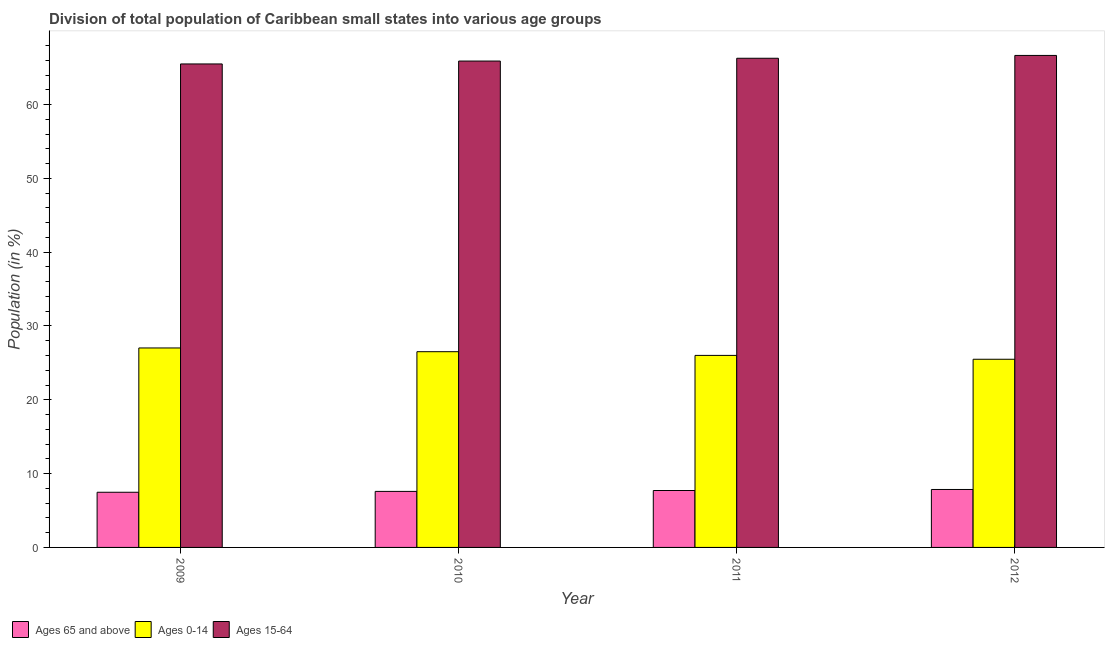How many groups of bars are there?
Give a very brief answer. 4. How many bars are there on the 1st tick from the right?
Give a very brief answer. 3. What is the percentage of population within the age-group 0-14 in 2010?
Provide a succinct answer. 26.52. Across all years, what is the maximum percentage of population within the age-group 0-14?
Ensure brevity in your answer.  27.02. Across all years, what is the minimum percentage of population within the age-group 15-64?
Your response must be concise. 65.5. In which year was the percentage of population within the age-group of 65 and above maximum?
Your answer should be compact. 2012. What is the total percentage of population within the age-group of 65 and above in the graph?
Your answer should be compact. 30.63. What is the difference between the percentage of population within the age-group of 65 and above in 2011 and that in 2012?
Provide a succinct answer. -0.14. What is the difference between the percentage of population within the age-group of 65 and above in 2011 and the percentage of population within the age-group 15-64 in 2012?
Provide a succinct answer. -0.14. What is the average percentage of population within the age-group of 65 and above per year?
Provide a succinct answer. 7.66. In how many years, is the percentage of population within the age-group 0-14 greater than 30 %?
Provide a short and direct response. 0. What is the ratio of the percentage of population within the age-group 15-64 in 2011 to that in 2012?
Make the answer very short. 0.99. What is the difference between the highest and the second highest percentage of population within the age-group 15-64?
Offer a very short reply. 0.38. What is the difference between the highest and the lowest percentage of population within the age-group of 65 and above?
Offer a terse response. 0.38. In how many years, is the percentage of population within the age-group of 65 and above greater than the average percentage of population within the age-group of 65 and above taken over all years?
Your response must be concise. 2. What does the 3rd bar from the left in 2010 represents?
Keep it short and to the point. Ages 15-64. What does the 2nd bar from the right in 2012 represents?
Ensure brevity in your answer.  Ages 0-14. Is it the case that in every year, the sum of the percentage of population within the age-group of 65 and above and percentage of population within the age-group 0-14 is greater than the percentage of population within the age-group 15-64?
Your answer should be very brief. No. How many bars are there?
Your answer should be compact. 12. Are all the bars in the graph horizontal?
Offer a very short reply. No. What is the difference between two consecutive major ticks on the Y-axis?
Make the answer very short. 10. Does the graph contain grids?
Your answer should be compact. No. How many legend labels are there?
Provide a short and direct response. 3. How are the legend labels stacked?
Provide a short and direct response. Horizontal. What is the title of the graph?
Your answer should be compact. Division of total population of Caribbean small states into various age groups
. What is the label or title of the Y-axis?
Your response must be concise. Population (in %). What is the Population (in %) of Ages 65 and above in 2009?
Your answer should be very brief. 7.48. What is the Population (in %) of Ages 0-14 in 2009?
Offer a terse response. 27.02. What is the Population (in %) in Ages 15-64 in 2009?
Ensure brevity in your answer.  65.5. What is the Population (in %) in Ages 65 and above in 2010?
Make the answer very short. 7.59. What is the Population (in %) of Ages 0-14 in 2010?
Your response must be concise. 26.52. What is the Population (in %) of Ages 15-64 in 2010?
Make the answer very short. 65.89. What is the Population (in %) of Ages 65 and above in 2011?
Your answer should be compact. 7.71. What is the Population (in %) in Ages 0-14 in 2011?
Your answer should be compact. 26.02. What is the Population (in %) in Ages 15-64 in 2011?
Ensure brevity in your answer.  66.27. What is the Population (in %) of Ages 65 and above in 2012?
Your answer should be very brief. 7.85. What is the Population (in %) in Ages 0-14 in 2012?
Provide a succinct answer. 25.49. What is the Population (in %) of Ages 15-64 in 2012?
Provide a succinct answer. 66.66. Across all years, what is the maximum Population (in %) of Ages 65 and above?
Provide a succinct answer. 7.85. Across all years, what is the maximum Population (in %) of Ages 0-14?
Give a very brief answer. 27.02. Across all years, what is the maximum Population (in %) in Ages 15-64?
Your answer should be very brief. 66.66. Across all years, what is the minimum Population (in %) of Ages 65 and above?
Your answer should be very brief. 7.48. Across all years, what is the minimum Population (in %) of Ages 0-14?
Provide a short and direct response. 25.49. Across all years, what is the minimum Population (in %) of Ages 15-64?
Your answer should be compact. 65.5. What is the total Population (in %) of Ages 65 and above in the graph?
Your answer should be compact. 30.63. What is the total Population (in %) of Ages 0-14 in the graph?
Provide a succinct answer. 105.05. What is the total Population (in %) in Ages 15-64 in the graph?
Offer a terse response. 264.32. What is the difference between the Population (in %) of Ages 65 and above in 2009 and that in 2010?
Offer a very short reply. -0.11. What is the difference between the Population (in %) of Ages 0-14 in 2009 and that in 2010?
Provide a succinct answer. 0.51. What is the difference between the Population (in %) of Ages 15-64 in 2009 and that in 2010?
Provide a succinct answer. -0.39. What is the difference between the Population (in %) in Ages 65 and above in 2009 and that in 2011?
Provide a succinct answer. -0.24. What is the difference between the Population (in %) in Ages 0-14 in 2009 and that in 2011?
Offer a very short reply. 1.01. What is the difference between the Population (in %) in Ages 15-64 in 2009 and that in 2011?
Keep it short and to the point. -0.77. What is the difference between the Population (in %) in Ages 65 and above in 2009 and that in 2012?
Keep it short and to the point. -0.38. What is the difference between the Population (in %) in Ages 0-14 in 2009 and that in 2012?
Your answer should be compact. 1.53. What is the difference between the Population (in %) of Ages 15-64 in 2009 and that in 2012?
Your response must be concise. -1.15. What is the difference between the Population (in %) of Ages 65 and above in 2010 and that in 2011?
Offer a very short reply. -0.12. What is the difference between the Population (in %) of Ages 0-14 in 2010 and that in 2011?
Provide a succinct answer. 0.5. What is the difference between the Population (in %) of Ages 15-64 in 2010 and that in 2011?
Ensure brevity in your answer.  -0.38. What is the difference between the Population (in %) in Ages 65 and above in 2010 and that in 2012?
Your answer should be compact. -0.26. What is the difference between the Population (in %) of Ages 0-14 in 2010 and that in 2012?
Make the answer very short. 1.02. What is the difference between the Population (in %) in Ages 15-64 in 2010 and that in 2012?
Give a very brief answer. -0.76. What is the difference between the Population (in %) in Ages 65 and above in 2011 and that in 2012?
Your answer should be compact. -0.14. What is the difference between the Population (in %) in Ages 0-14 in 2011 and that in 2012?
Make the answer very short. 0.52. What is the difference between the Population (in %) in Ages 15-64 in 2011 and that in 2012?
Your response must be concise. -0.38. What is the difference between the Population (in %) of Ages 65 and above in 2009 and the Population (in %) of Ages 0-14 in 2010?
Keep it short and to the point. -19.04. What is the difference between the Population (in %) of Ages 65 and above in 2009 and the Population (in %) of Ages 15-64 in 2010?
Your answer should be compact. -58.42. What is the difference between the Population (in %) of Ages 0-14 in 2009 and the Population (in %) of Ages 15-64 in 2010?
Make the answer very short. -38.87. What is the difference between the Population (in %) in Ages 65 and above in 2009 and the Population (in %) in Ages 0-14 in 2011?
Provide a short and direct response. -18.54. What is the difference between the Population (in %) of Ages 65 and above in 2009 and the Population (in %) of Ages 15-64 in 2011?
Offer a very short reply. -58.8. What is the difference between the Population (in %) of Ages 0-14 in 2009 and the Population (in %) of Ages 15-64 in 2011?
Offer a terse response. -39.25. What is the difference between the Population (in %) in Ages 65 and above in 2009 and the Population (in %) in Ages 0-14 in 2012?
Ensure brevity in your answer.  -18.02. What is the difference between the Population (in %) in Ages 65 and above in 2009 and the Population (in %) in Ages 15-64 in 2012?
Offer a very short reply. -59.18. What is the difference between the Population (in %) in Ages 0-14 in 2009 and the Population (in %) in Ages 15-64 in 2012?
Offer a terse response. -39.63. What is the difference between the Population (in %) in Ages 65 and above in 2010 and the Population (in %) in Ages 0-14 in 2011?
Ensure brevity in your answer.  -18.43. What is the difference between the Population (in %) in Ages 65 and above in 2010 and the Population (in %) in Ages 15-64 in 2011?
Make the answer very short. -58.68. What is the difference between the Population (in %) of Ages 0-14 in 2010 and the Population (in %) of Ages 15-64 in 2011?
Keep it short and to the point. -39.76. What is the difference between the Population (in %) of Ages 65 and above in 2010 and the Population (in %) of Ages 0-14 in 2012?
Offer a very short reply. -17.9. What is the difference between the Population (in %) in Ages 65 and above in 2010 and the Population (in %) in Ages 15-64 in 2012?
Give a very brief answer. -59.07. What is the difference between the Population (in %) in Ages 0-14 in 2010 and the Population (in %) in Ages 15-64 in 2012?
Give a very brief answer. -40.14. What is the difference between the Population (in %) in Ages 65 and above in 2011 and the Population (in %) in Ages 0-14 in 2012?
Give a very brief answer. -17.78. What is the difference between the Population (in %) in Ages 65 and above in 2011 and the Population (in %) in Ages 15-64 in 2012?
Offer a very short reply. -58.94. What is the difference between the Population (in %) in Ages 0-14 in 2011 and the Population (in %) in Ages 15-64 in 2012?
Provide a short and direct response. -40.64. What is the average Population (in %) in Ages 65 and above per year?
Ensure brevity in your answer.  7.66. What is the average Population (in %) in Ages 0-14 per year?
Offer a very short reply. 26.26. What is the average Population (in %) of Ages 15-64 per year?
Provide a succinct answer. 66.08. In the year 2009, what is the difference between the Population (in %) in Ages 65 and above and Population (in %) in Ages 0-14?
Offer a very short reply. -19.55. In the year 2009, what is the difference between the Population (in %) in Ages 65 and above and Population (in %) in Ages 15-64?
Your answer should be very brief. -58.03. In the year 2009, what is the difference between the Population (in %) in Ages 0-14 and Population (in %) in Ages 15-64?
Provide a short and direct response. -38.48. In the year 2010, what is the difference between the Population (in %) in Ages 65 and above and Population (in %) in Ages 0-14?
Provide a short and direct response. -18.93. In the year 2010, what is the difference between the Population (in %) of Ages 65 and above and Population (in %) of Ages 15-64?
Your answer should be very brief. -58.3. In the year 2010, what is the difference between the Population (in %) of Ages 0-14 and Population (in %) of Ages 15-64?
Ensure brevity in your answer.  -39.38. In the year 2011, what is the difference between the Population (in %) in Ages 65 and above and Population (in %) in Ages 0-14?
Make the answer very short. -18.3. In the year 2011, what is the difference between the Population (in %) of Ages 65 and above and Population (in %) of Ages 15-64?
Make the answer very short. -58.56. In the year 2011, what is the difference between the Population (in %) in Ages 0-14 and Population (in %) in Ages 15-64?
Your answer should be compact. -40.26. In the year 2012, what is the difference between the Population (in %) in Ages 65 and above and Population (in %) in Ages 0-14?
Offer a very short reply. -17.64. In the year 2012, what is the difference between the Population (in %) in Ages 65 and above and Population (in %) in Ages 15-64?
Keep it short and to the point. -58.81. In the year 2012, what is the difference between the Population (in %) of Ages 0-14 and Population (in %) of Ages 15-64?
Offer a very short reply. -41.16. What is the ratio of the Population (in %) of Ages 65 and above in 2009 to that in 2010?
Ensure brevity in your answer.  0.98. What is the ratio of the Population (in %) in Ages 0-14 in 2009 to that in 2010?
Make the answer very short. 1.02. What is the ratio of the Population (in %) in Ages 65 and above in 2009 to that in 2011?
Provide a short and direct response. 0.97. What is the ratio of the Population (in %) of Ages 0-14 in 2009 to that in 2011?
Your answer should be compact. 1.04. What is the ratio of the Population (in %) in Ages 15-64 in 2009 to that in 2011?
Give a very brief answer. 0.99. What is the ratio of the Population (in %) in Ages 65 and above in 2009 to that in 2012?
Give a very brief answer. 0.95. What is the ratio of the Population (in %) in Ages 0-14 in 2009 to that in 2012?
Your answer should be compact. 1.06. What is the ratio of the Population (in %) of Ages 15-64 in 2009 to that in 2012?
Provide a short and direct response. 0.98. What is the ratio of the Population (in %) in Ages 65 and above in 2010 to that in 2011?
Give a very brief answer. 0.98. What is the ratio of the Population (in %) in Ages 0-14 in 2010 to that in 2011?
Provide a succinct answer. 1.02. What is the ratio of the Population (in %) in Ages 15-64 in 2010 to that in 2011?
Your answer should be very brief. 0.99. What is the ratio of the Population (in %) in Ages 65 and above in 2010 to that in 2012?
Give a very brief answer. 0.97. What is the ratio of the Population (in %) of Ages 0-14 in 2010 to that in 2012?
Your response must be concise. 1.04. What is the ratio of the Population (in %) in Ages 15-64 in 2010 to that in 2012?
Offer a very short reply. 0.99. What is the ratio of the Population (in %) of Ages 65 and above in 2011 to that in 2012?
Keep it short and to the point. 0.98. What is the ratio of the Population (in %) in Ages 0-14 in 2011 to that in 2012?
Provide a short and direct response. 1.02. What is the ratio of the Population (in %) of Ages 15-64 in 2011 to that in 2012?
Provide a succinct answer. 0.99. What is the difference between the highest and the second highest Population (in %) in Ages 65 and above?
Your response must be concise. 0.14. What is the difference between the highest and the second highest Population (in %) in Ages 0-14?
Provide a short and direct response. 0.51. What is the difference between the highest and the second highest Population (in %) in Ages 15-64?
Your answer should be very brief. 0.38. What is the difference between the highest and the lowest Population (in %) of Ages 65 and above?
Offer a terse response. 0.38. What is the difference between the highest and the lowest Population (in %) of Ages 0-14?
Provide a succinct answer. 1.53. What is the difference between the highest and the lowest Population (in %) of Ages 15-64?
Provide a short and direct response. 1.15. 